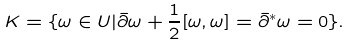Convert formula to latex. <formula><loc_0><loc_0><loc_500><loc_500>K = \{ \omega \in U | \bar { \partial } \omega + \frac { 1 } { 2 } [ \omega , \omega ] = \bar { \partial } ^ { * } \omega = 0 \} .</formula> 